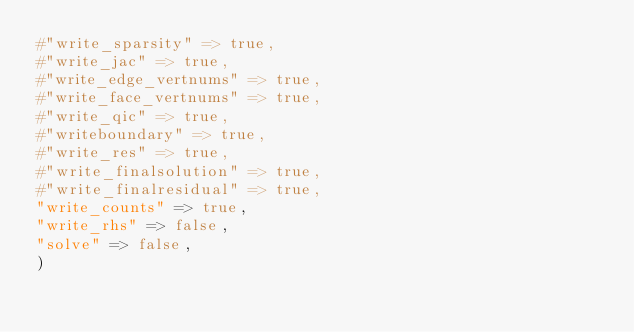<code> <loc_0><loc_0><loc_500><loc_500><_Julia_>#"write_sparsity" => true,
#"write_jac" => true,
#"write_edge_vertnums" => true,
#"write_face_vertnums" => true,
#"write_qic" => true,
#"writeboundary" => true,
#"write_res" => true,
#"write_finalsolution" => true,
#"write_finalresidual" => true,
"write_counts" => true,
"write_rhs" => false,
"solve" => false,
)
</code> 